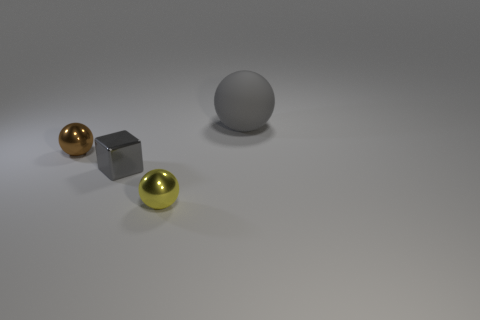Add 3 large red blocks. How many objects exist? 7 Subtract all small metallic spheres. How many spheres are left? 1 Subtract all balls. How many objects are left? 1 Subtract 1 blocks. How many blocks are left? 0 Subtract all gray balls. Subtract all red cylinders. How many balls are left? 2 Subtract all brown cylinders. How many cyan blocks are left? 0 Subtract all brown objects. Subtract all large purple rubber things. How many objects are left? 3 Add 4 tiny spheres. How many tiny spheres are left? 6 Add 1 tiny purple rubber objects. How many tiny purple rubber objects exist? 1 Subtract 0 cyan cylinders. How many objects are left? 4 